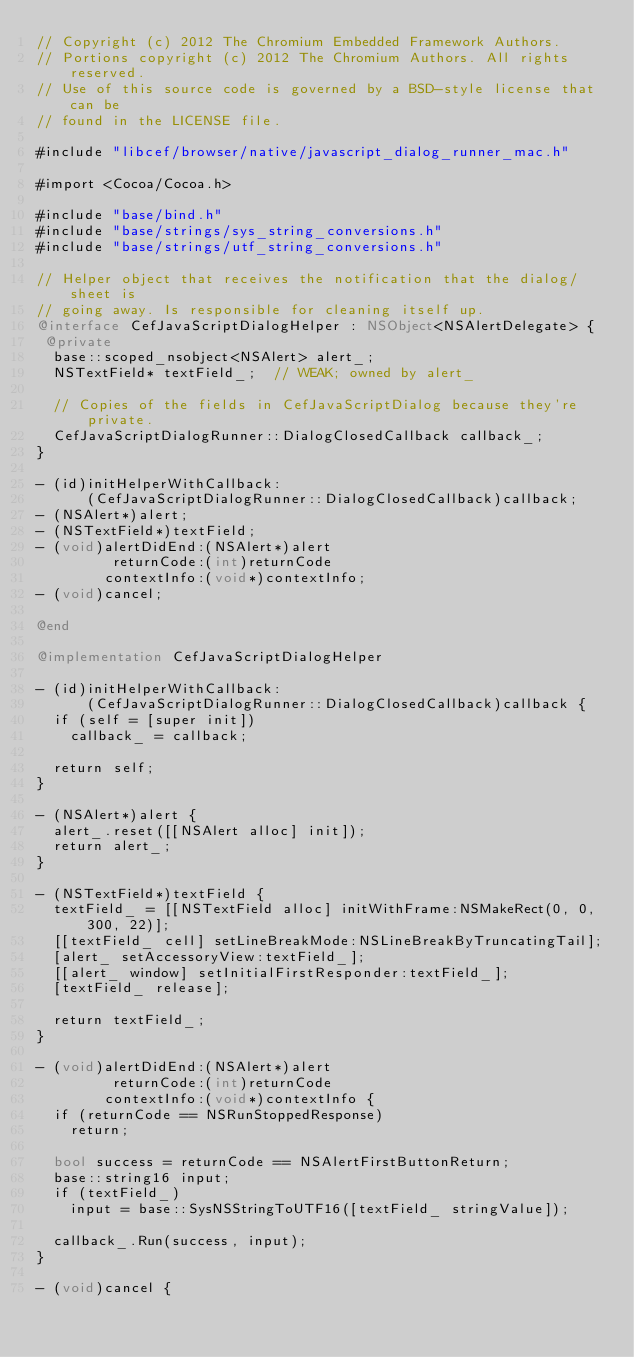<code> <loc_0><loc_0><loc_500><loc_500><_ObjectiveC_>// Copyright (c) 2012 The Chromium Embedded Framework Authors.
// Portions copyright (c) 2012 The Chromium Authors. All rights reserved.
// Use of this source code is governed by a BSD-style license that can be
// found in the LICENSE file.

#include "libcef/browser/native/javascript_dialog_runner_mac.h"

#import <Cocoa/Cocoa.h>

#include "base/bind.h"
#include "base/strings/sys_string_conversions.h"
#include "base/strings/utf_string_conversions.h"

// Helper object that receives the notification that the dialog/sheet is
// going away. Is responsible for cleaning itself up.
@interface CefJavaScriptDialogHelper : NSObject<NSAlertDelegate> {
 @private
  base::scoped_nsobject<NSAlert> alert_;
  NSTextField* textField_;  // WEAK; owned by alert_

  // Copies of the fields in CefJavaScriptDialog because they're private.
  CefJavaScriptDialogRunner::DialogClosedCallback callback_;
}

- (id)initHelperWithCallback:
      (CefJavaScriptDialogRunner::DialogClosedCallback)callback;
- (NSAlert*)alert;
- (NSTextField*)textField;
- (void)alertDidEnd:(NSAlert*)alert
         returnCode:(int)returnCode
        contextInfo:(void*)contextInfo;
- (void)cancel;

@end

@implementation CefJavaScriptDialogHelper

- (id)initHelperWithCallback:
      (CefJavaScriptDialogRunner::DialogClosedCallback)callback {
  if (self = [super init])
    callback_ = callback;

  return self;
}

- (NSAlert*)alert {
  alert_.reset([[NSAlert alloc] init]);
  return alert_;
}

- (NSTextField*)textField {
  textField_ = [[NSTextField alloc] initWithFrame:NSMakeRect(0, 0, 300, 22)];
  [[textField_ cell] setLineBreakMode:NSLineBreakByTruncatingTail];
  [alert_ setAccessoryView:textField_];
  [[alert_ window] setInitialFirstResponder:textField_];
  [textField_ release];

  return textField_;
}

- (void)alertDidEnd:(NSAlert*)alert
         returnCode:(int)returnCode
        contextInfo:(void*)contextInfo {
  if (returnCode == NSRunStoppedResponse)
    return;

  bool success = returnCode == NSAlertFirstButtonReturn;
  base::string16 input;
  if (textField_)
    input = base::SysNSStringToUTF16([textField_ stringValue]);

  callback_.Run(success, input);
}

- (void)cancel {</code> 